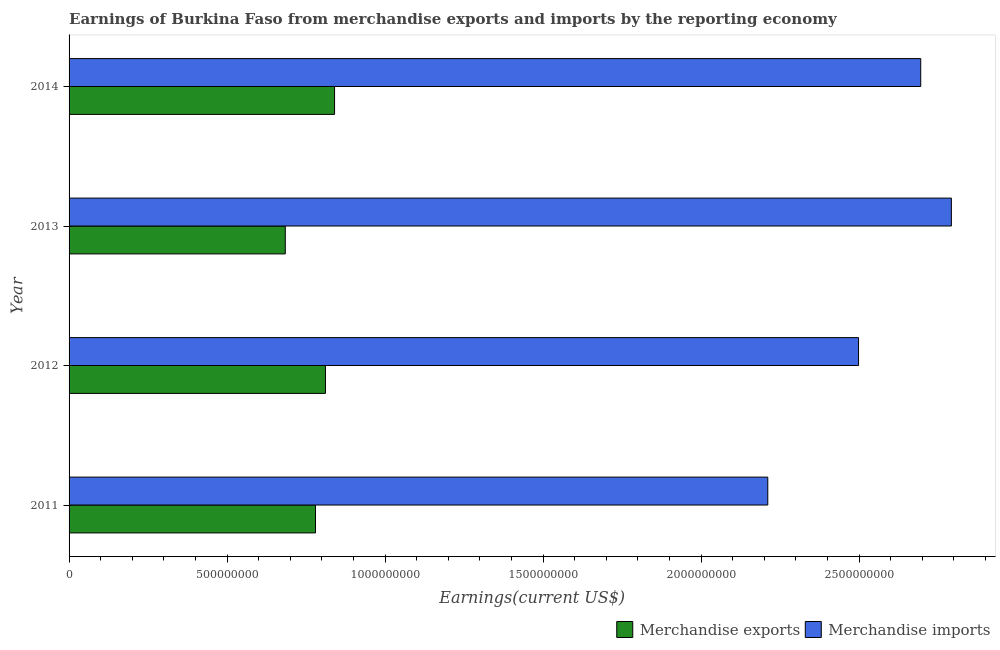How many different coloured bars are there?
Ensure brevity in your answer.  2. Are the number of bars per tick equal to the number of legend labels?
Offer a very short reply. Yes. Are the number of bars on each tick of the Y-axis equal?
Provide a succinct answer. Yes. How many bars are there on the 4th tick from the top?
Your response must be concise. 2. How many bars are there on the 2nd tick from the bottom?
Offer a very short reply. 2. In how many cases, is the number of bars for a given year not equal to the number of legend labels?
Offer a terse response. 0. What is the earnings from merchandise exports in 2011?
Your answer should be very brief. 7.80e+08. Across all years, what is the maximum earnings from merchandise exports?
Give a very brief answer. 8.40e+08. Across all years, what is the minimum earnings from merchandise imports?
Ensure brevity in your answer.  2.21e+09. In which year was the earnings from merchandise imports minimum?
Offer a very short reply. 2011. What is the total earnings from merchandise exports in the graph?
Give a very brief answer. 3.12e+09. What is the difference between the earnings from merchandise exports in 2011 and that in 2013?
Provide a short and direct response. 9.56e+07. What is the difference between the earnings from merchandise exports in 2014 and the earnings from merchandise imports in 2012?
Your response must be concise. -1.66e+09. What is the average earnings from merchandise exports per year?
Give a very brief answer. 7.79e+08. In the year 2011, what is the difference between the earnings from merchandise imports and earnings from merchandise exports?
Keep it short and to the point. 1.43e+09. In how many years, is the earnings from merchandise imports greater than 100000000 US$?
Your answer should be compact. 4. What is the difference between the highest and the second highest earnings from merchandise imports?
Provide a succinct answer. 9.70e+07. What is the difference between the highest and the lowest earnings from merchandise imports?
Provide a succinct answer. 5.81e+08. In how many years, is the earnings from merchandise exports greater than the average earnings from merchandise exports taken over all years?
Your answer should be very brief. 3. Is the sum of the earnings from merchandise imports in 2011 and 2012 greater than the maximum earnings from merchandise exports across all years?
Offer a very short reply. Yes. How many bars are there?
Give a very brief answer. 8. Are all the bars in the graph horizontal?
Provide a short and direct response. Yes. How many years are there in the graph?
Offer a terse response. 4. What is the difference between two consecutive major ticks on the X-axis?
Offer a terse response. 5.00e+08. Are the values on the major ticks of X-axis written in scientific E-notation?
Offer a very short reply. No. What is the title of the graph?
Your answer should be very brief. Earnings of Burkina Faso from merchandise exports and imports by the reporting economy. Does "Urban Population" appear as one of the legend labels in the graph?
Give a very brief answer. No. What is the label or title of the X-axis?
Provide a succinct answer. Earnings(current US$). What is the label or title of the Y-axis?
Keep it short and to the point. Year. What is the Earnings(current US$) of Merchandise exports in 2011?
Your answer should be very brief. 7.80e+08. What is the Earnings(current US$) of Merchandise imports in 2011?
Keep it short and to the point. 2.21e+09. What is the Earnings(current US$) in Merchandise exports in 2012?
Give a very brief answer. 8.11e+08. What is the Earnings(current US$) of Merchandise imports in 2012?
Keep it short and to the point. 2.50e+09. What is the Earnings(current US$) in Merchandise exports in 2013?
Make the answer very short. 6.84e+08. What is the Earnings(current US$) in Merchandise imports in 2013?
Keep it short and to the point. 2.79e+09. What is the Earnings(current US$) of Merchandise exports in 2014?
Provide a succinct answer. 8.40e+08. What is the Earnings(current US$) of Merchandise imports in 2014?
Provide a succinct answer. 2.70e+09. Across all years, what is the maximum Earnings(current US$) of Merchandise exports?
Your response must be concise. 8.40e+08. Across all years, what is the maximum Earnings(current US$) in Merchandise imports?
Your answer should be compact. 2.79e+09. Across all years, what is the minimum Earnings(current US$) of Merchandise exports?
Make the answer very short. 6.84e+08. Across all years, what is the minimum Earnings(current US$) of Merchandise imports?
Offer a very short reply. 2.21e+09. What is the total Earnings(current US$) of Merchandise exports in the graph?
Give a very brief answer. 3.12e+09. What is the total Earnings(current US$) in Merchandise imports in the graph?
Ensure brevity in your answer.  1.02e+1. What is the difference between the Earnings(current US$) in Merchandise exports in 2011 and that in 2012?
Provide a short and direct response. -3.15e+07. What is the difference between the Earnings(current US$) in Merchandise imports in 2011 and that in 2012?
Make the answer very short. -2.87e+08. What is the difference between the Earnings(current US$) in Merchandise exports in 2011 and that in 2013?
Give a very brief answer. 9.56e+07. What is the difference between the Earnings(current US$) in Merchandise imports in 2011 and that in 2013?
Your response must be concise. -5.81e+08. What is the difference between the Earnings(current US$) of Merchandise exports in 2011 and that in 2014?
Your answer should be compact. -6.03e+07. What is the difference between the Earnings(current US$) of Merchandise imports in 2011 and that in 2014?
Give a very brief answer. -4.84e+08. What is the difference between the Earnings(current US$) of Merchandise exports in 2012 and that in 2013?
Your response must be concise. 1.27e+08. What is the difference between the Earnings(current US$) in Merchandise imports in 2012 and that in 2013?
Give a very brief answer. -2.94e+08. What is the difference between the Earnings(current US$) in Merchandise exports in 2012 and that in 2014?
Make the answer very short. -2.88e+07. What is the difference between the Earnings(current US$) in Merchandise imports in 2012 and that in 2014?
Make the answer very short. -1.97e+08. What is the difference between the Earnings(current US$) of Merchandise exports in 2013 and that in 2014?
Your response must be concise. -1.56e+08. What is the difference between the Earnings(current US$) of Merchandise imports in 2013 and that in 2014?
Your answer should be compact. 9.70e+07. What is the difference between the Earnings(current US$) in Merchandise exports in 2011 and the Earnings(current US$) in Merchandise imports in 2012?
Offer a terse response. -1.72e+09. What is the difference between the Earnings(current US$) of Merchandise exports in 2011 and the Earnings(current US$) of Merchandise imports in 2013?
Your response must be concise. -2.01e+09. What is the difference between the Earnings(current US$) in Merchandise exports in 2011 and the Earnings(current US$) in Merchandise imports in 2014?
Offer a terse response. -1.92e+09. What is the difference between the Earnings(current US$) of Merchandise exports in 2012 and the Earnings(current US$) of Merchandise imports in 2013?
Your response must be concise. -1.98e+09. What is the difference between the Earnings(current US$) in Merchandise exports in 2012 and the Earnings(current US$) in Merchandise imports in 2014?
Offer a terse response. -1.88e+09. What is the difference between the Earnings(current US$) in Merchandise exports in 2013 and the Earnings(current US$) in Merchandise imports in 2014?
Ensure brevity in your answer.  -2.01e+09. What is the average Earnings(current US$) of Merchandise exports per year?
Provide a succinct answer. 7.79e+08. What is the average Earnings(current US$) of Merchandise imports per year?
Your answer should be compact. 2.55e+09. In the year 2011, what is the difference between the Earnings(current US$) of Merchandise exports and Earnings(current US$) of Merchandise imports?
Provide a succinct answer. -1.43e+09. In the year 2012, what is the difference between the Earnings(current US$) of Merchandise exports and Earnings(current US$) of Merchandise imports?
Your answer should be compact. -1.69e+09. In the year 2013, what is the difference between the Earnings(current US$) in Merchandise exports and Earnings(current US$) in Merchandise imports?
Keep it short and to the point. -2.11e+09. In the year 2014, what is the difference between the Earnings(current US$) of Merchandise exports and Earnings(current US$) of Merchandise imports?
Offer a terse response. -1.85e+09. What is the ratio of the Earnings(current US$) of Merchandise exports in 2011 to that in 2012?
Offer a very short reply. 0.96. What is the ratio of the Earnings(current US$) of Merchandise imports in 2011 to that in 2012?
Ensure brevity in your answer.  0.89. What is the ratio of the Earnings(current US$) in Merchandise exports in 2011 to that in 2013?
Offer a very short reply. 1.14. What is the ratio of the Earnings(current US$) of Merchandise imports in 2011 to that in 2013?
Ensure brevity in your answer.  0.79. What is the ratio of the Earnings(current US$) in Merchandise exports in 2011 to that in 2014?
Your answer should be very brief. 0.93. What is the ratio of the Earnings(current US$) in Merchandise imports in 2011 to that in 2014?
Give a very brief answer. 0.82. What is the ratio of the Earnings(current US$) of Merchandise exports in 2012 to that in 2013?
Offer a terse response. 1.19. What is the ratio of the Earnings(current US$) in Merchandise imports in 2012 to that in 2013?
Your answer should be compact. 0.89. What is the ratio of the Earnings(current US$) of Merchandise exports in 2012 to that in 2014?
Offer a terse response. 0.97. What is the ratio of the Earnings(current US$) of Merchandise imports in 2012 to that in 2014?
Your answer should be compact. 0.93. What is the ratio of the Earnings(current US$) in Merchandise exports in 2013 to that in 2014?
Offer a very short reply. 0.81. What is the ratio of the Earnings(current US$) in Merchandise imports in 2013 to that in 2014?
Make the answer very short. 1.04. What is the difference between the highest and the second highest Earnings(current US$) in Merchandise exports?
Provide a short and direct response. 2.88e+07. What is the difference between the highest and the second highest Earnings(current US$) of Merchandise imports?
Offer a terse response. 9.70e+07. What is the difference between the highest and the lowest Earnings(current US$) in Merchandise exports?
Your answer should be very brief. 1.56e+08. What is the difference between the highest and the lowest Earnings(current US$) of Merchandise imports?
Provide a short and direct response. 5.81e+08. 